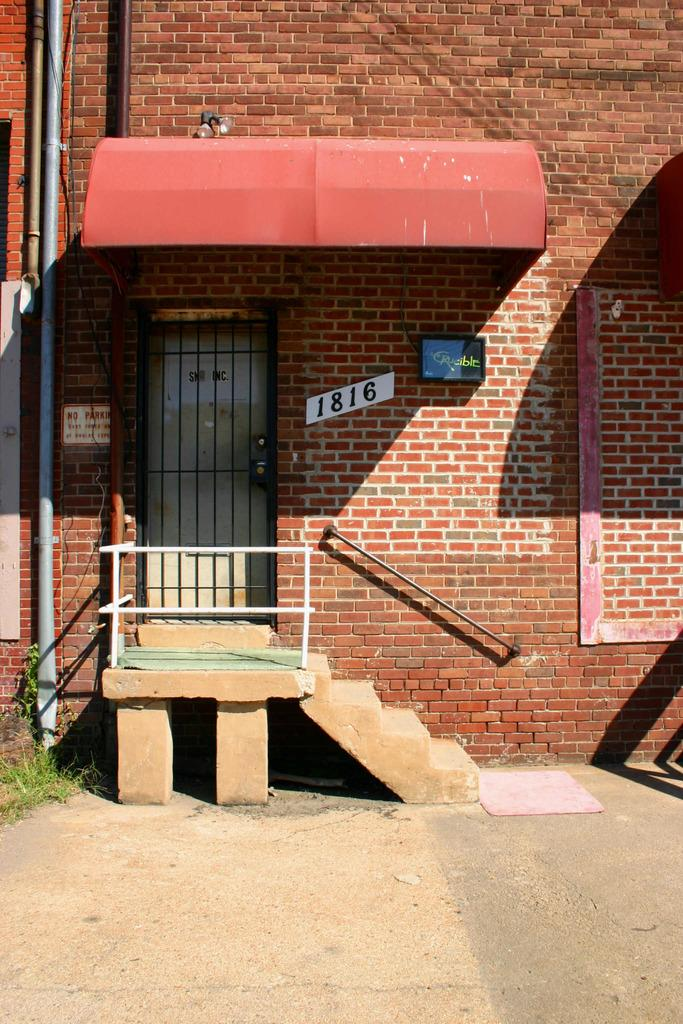What type of structure can be seen in the image? There is a wall with a door in the image. What can be found near the wall? There are pipes visible in the image. What is located on the wall? There is a board in the image. What type of illumination is present in the image? There are lights in the image. What type of building or shelter is visible in the image? There is a shed in the image. How can someone access the higher level in the image? There are stairs in the image. What safety feature is present near the stairs? There is a railing in the image. What is placed on the ground in the image? There is a mat on the ground in the image. How many planes are parked on the mat in the image? There are no planes present in the image; it features a wall with a door, pipes, a board, lights, a shed, stairs, a railing, and a mat on the ground. 